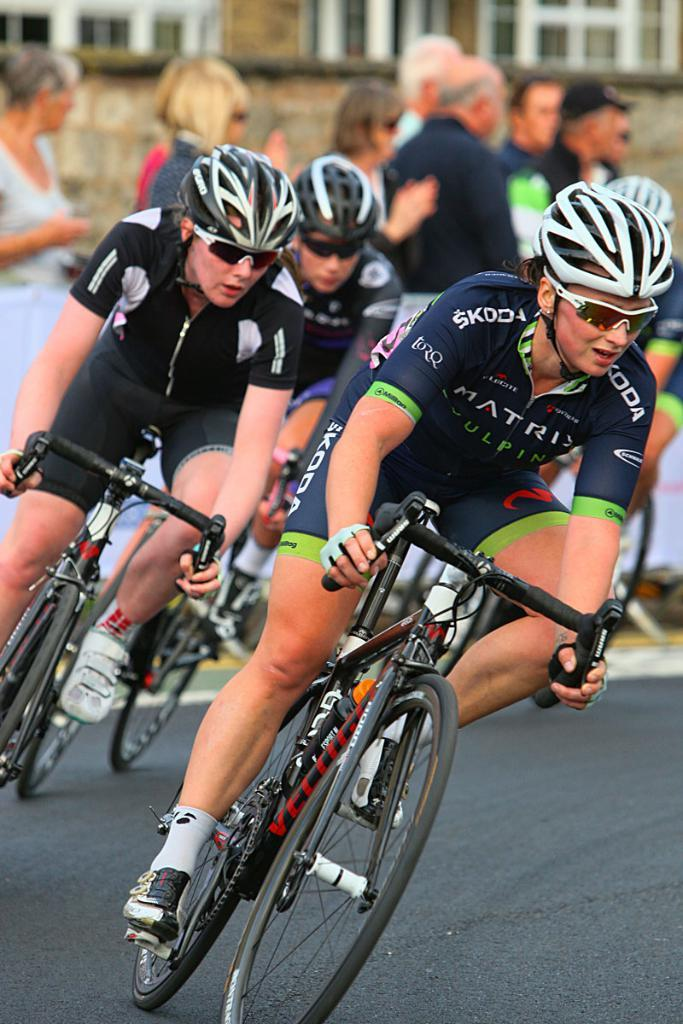How many people are riding the bicycle in the image? There are three persons riding the bicycle in the image. What safety equipment are the persons wearing while riding the bicycle? The persons are wearing helmets and goggles or glasses. What can be seen in the background of the image? There is a road and a building visible in the image. What type of basketball court can be seen in the image? There is no basketball court present in the image. 